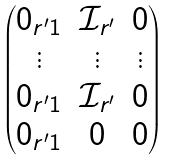Convert formula to latex. <formula><loc_0><loc_0><loc_500><loc_500>\begin{pmatrix} 0 _ { r ^ { \prime } 1 } & \mathcal { I } _ { r ^ { \prime } } & 0 \\ \vdots & \vdots & \vdots \\ 0 _ { r ^ { \prime } 1 } & \mathcal { I } _ { r ^ { \prime } } & 0 \\ 0 _ { r ^ { \prime } 1 } & 0 & 0 \end{pmatrix}</formula> 